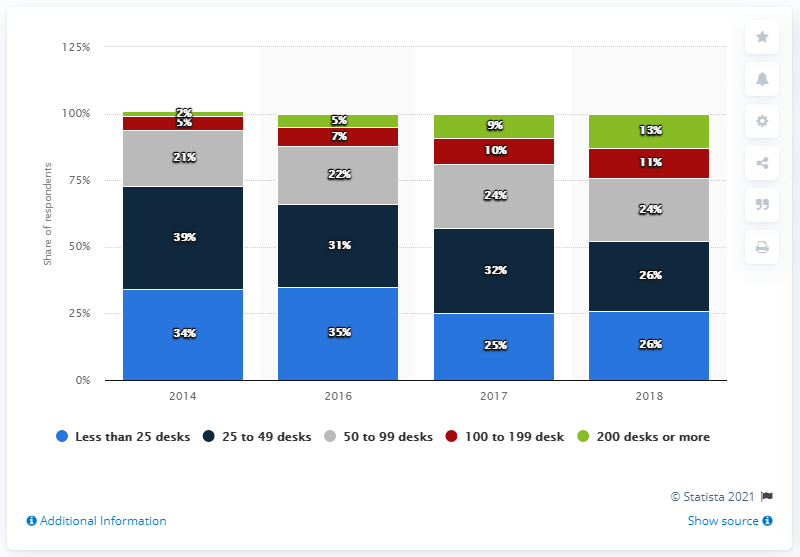Outline some significant characteristics in this image. The average of all the blue bars is 30. In 2018, the percentage value of green bars was 13%. 